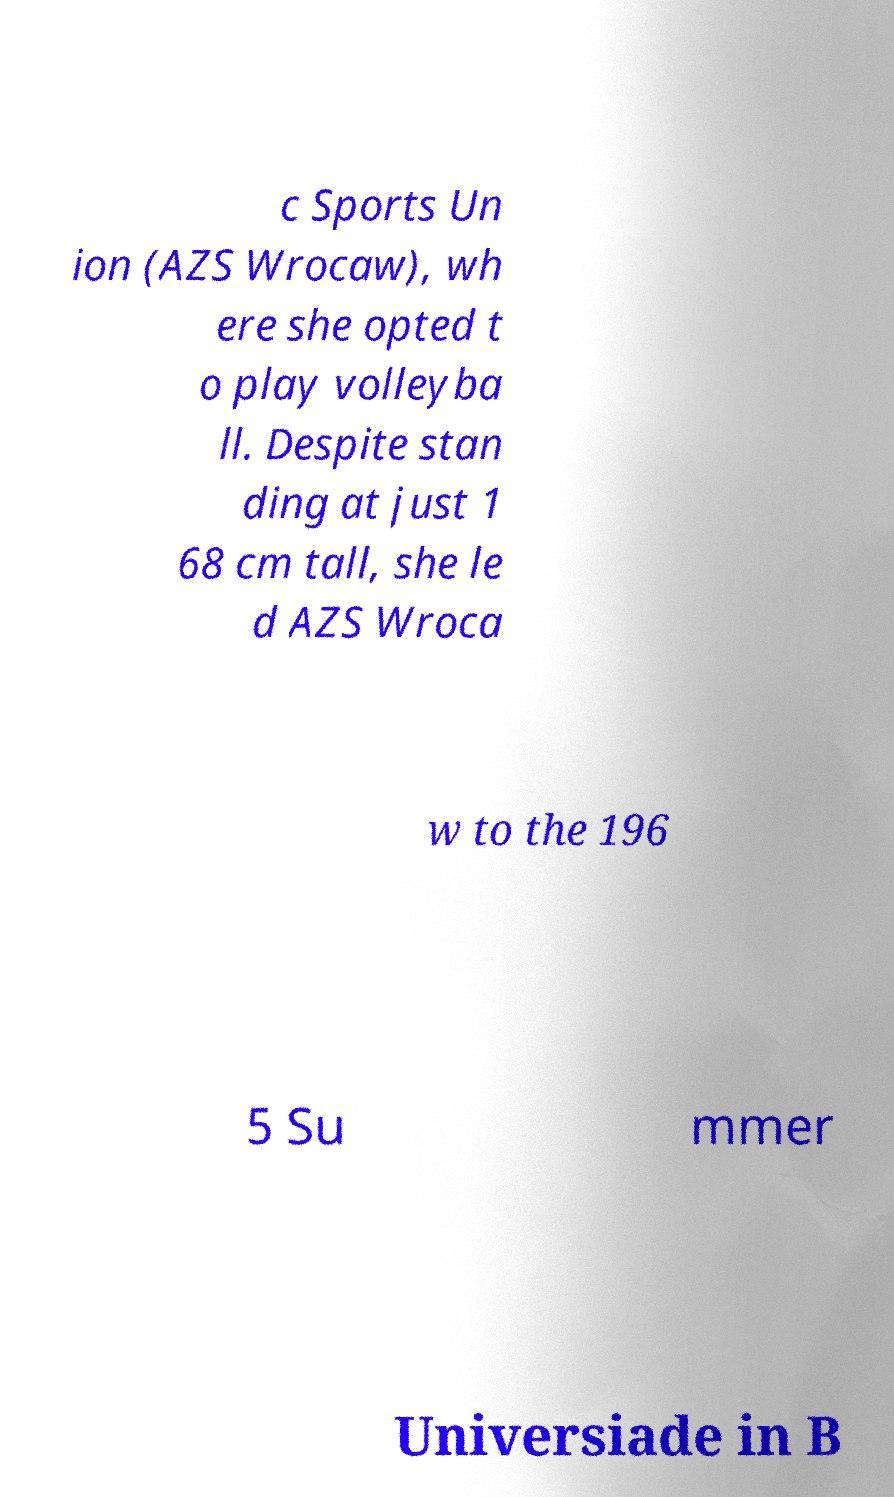Can you read and provide the text displayed in the image?This photo seems to have some interesting text. Can you extract and type it out for me? c Sports Un ion (AZS Wrocaw), wh ere she opted t o play volleyba ll. Despite stan ding at just 1 68 cm tall, she le d AZS Wroca w to the 196 5 Su mmer Universiade in B 